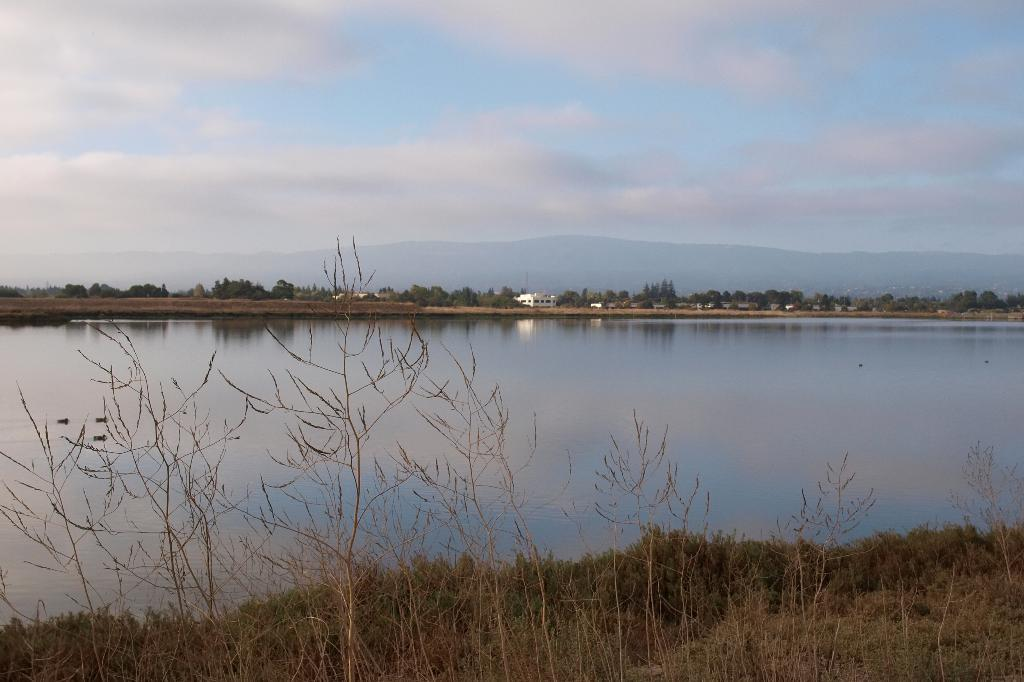What is the primary element visible in the image? There is water in the image. What type of vegetation can be seen growing in the image? There are grass plants and trees in the image. What type of structure is present in the image? There is a house in the image. What is visible in the background of the image? The sky is visible in the image, and clouds are present in the sky. What type of jam is being spread on the toast in the image? There is no toast or jam present in the image. How many eggs are visible in the image? There are no eggs visible in the image. 